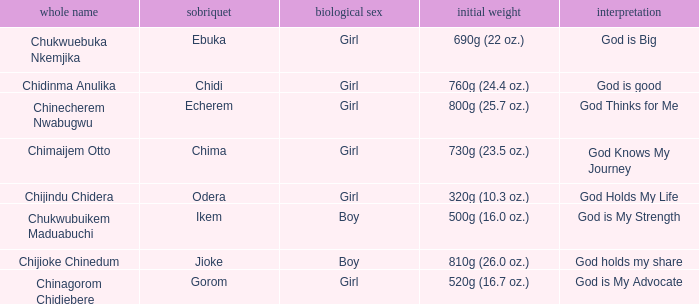Chukwubuikem Maduabuchi is what gender? Boy. 